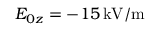Convert formula to latex. <formula><loc_0><loc_0><loc_500><loc_500>E _ { 0 z } = - 1 5 \, k V / m</formula> 